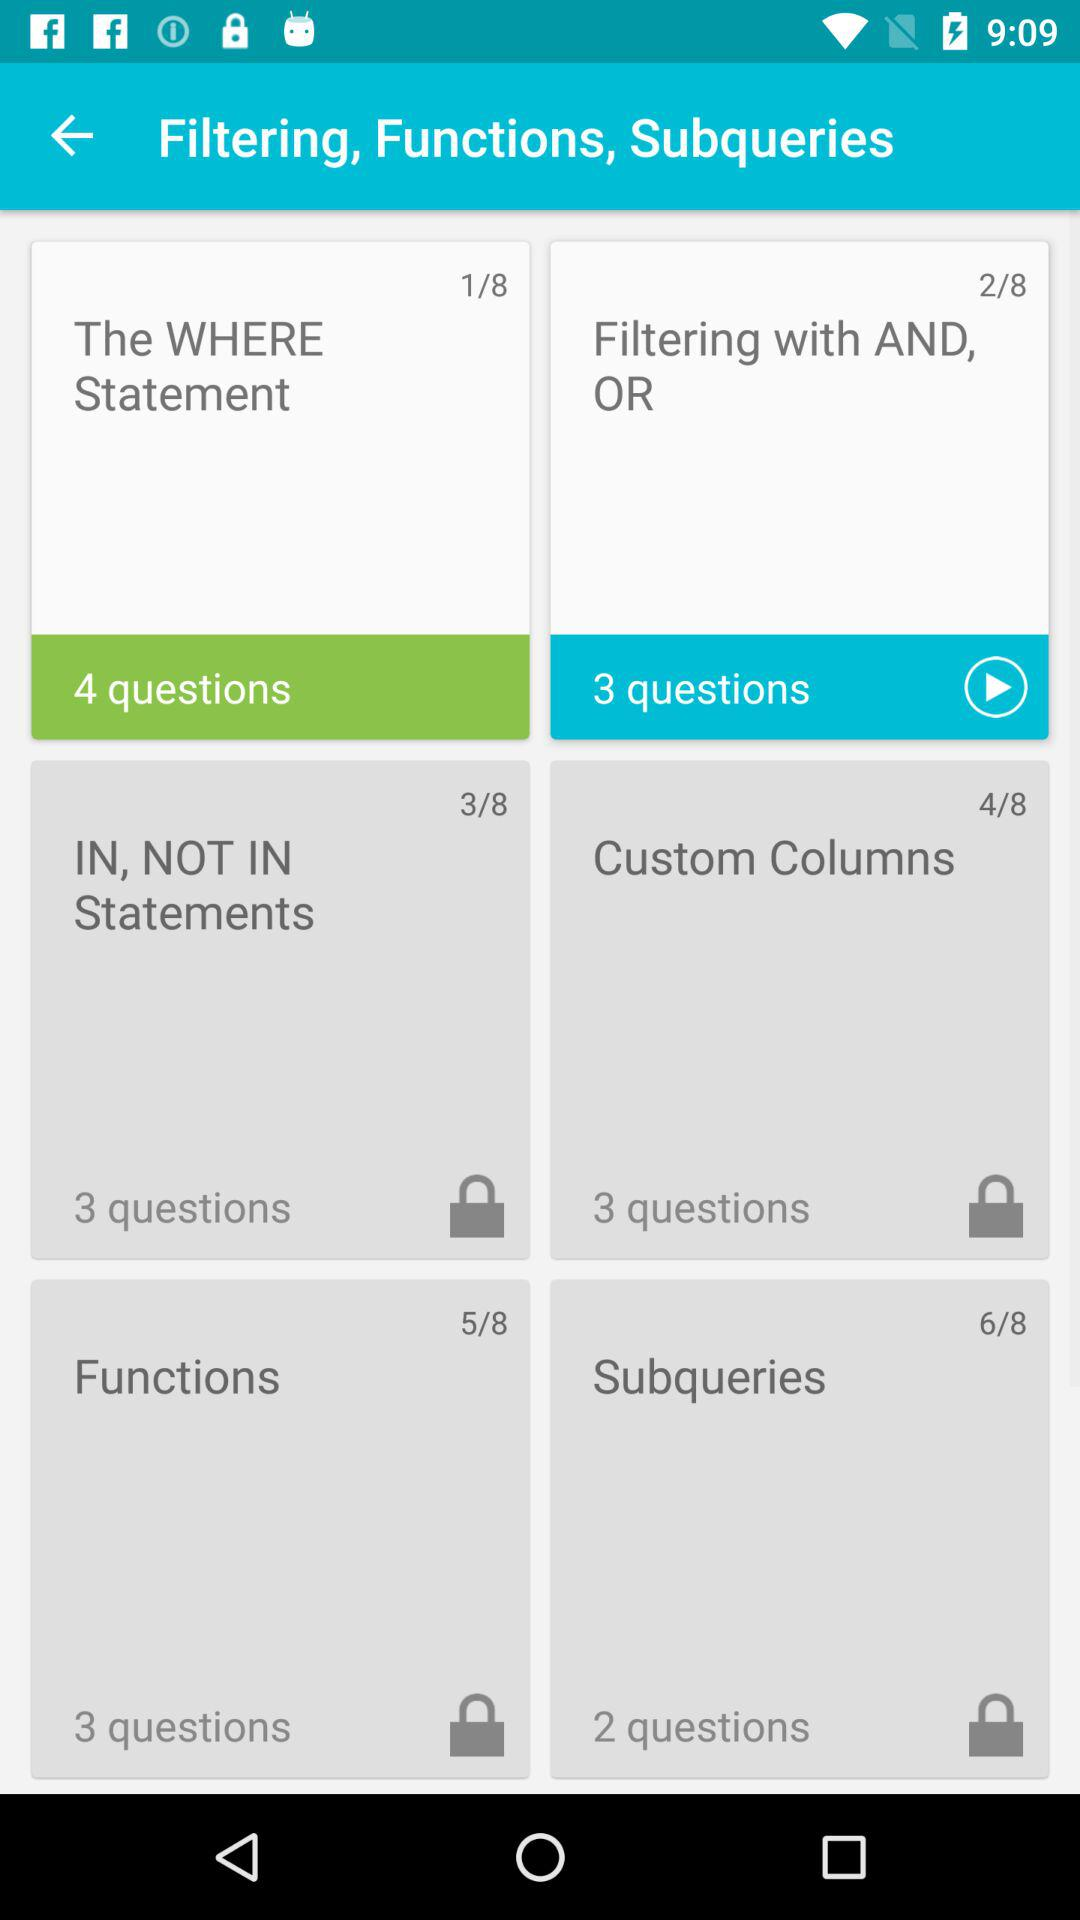How many questions are there in "The WHERE Statement"? There are 4 questions. 